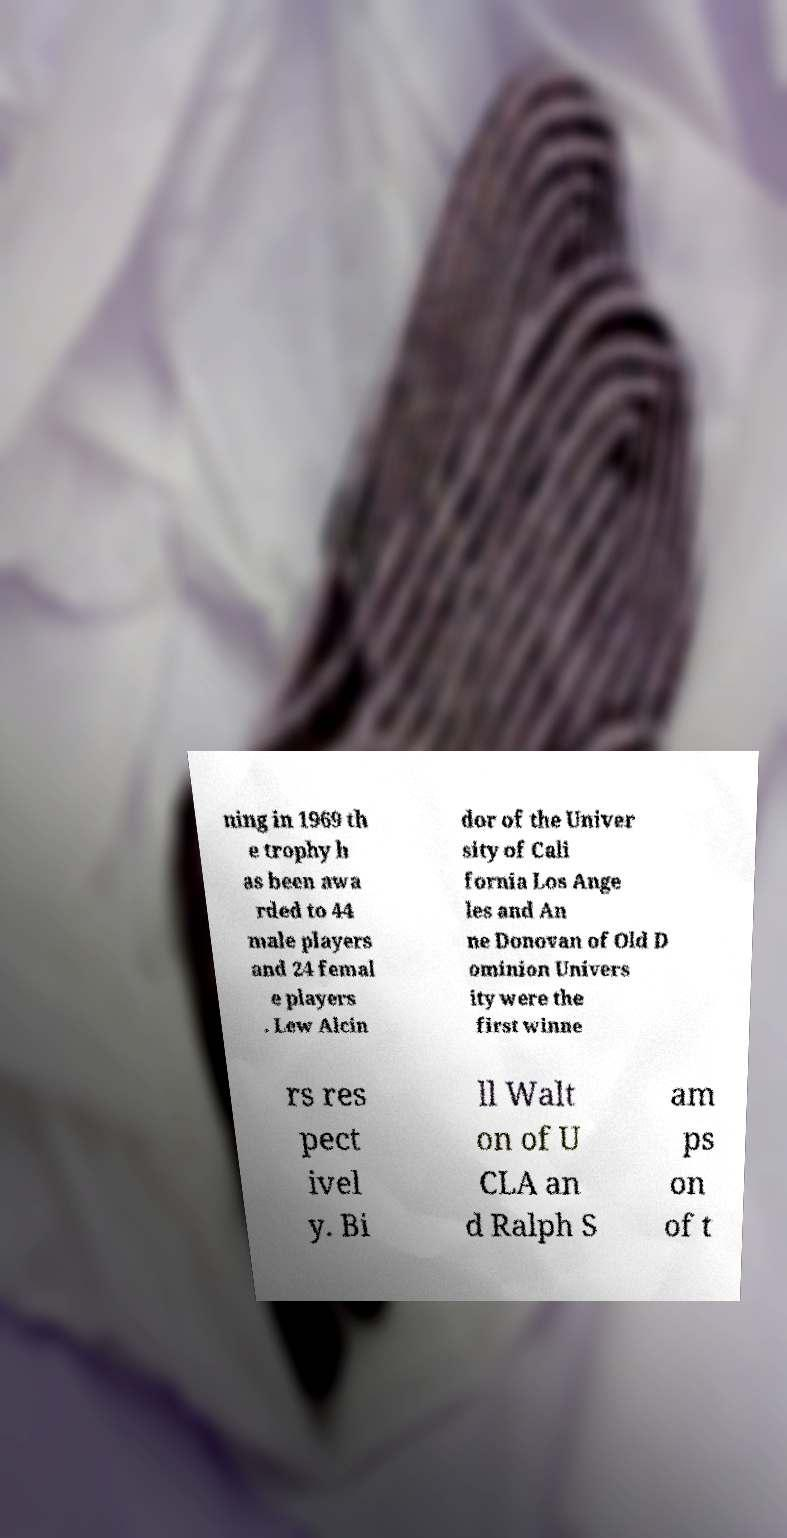I need the written content from this picture converted into text. Can you do that? ning in 1969 th e trophy h as been awa rded to 44 male players and 24 femal e players . Lew Alcin dor of the Univer sity of Cali fornia Los Ange les and An ne Donovan of Old D ominion Univers ity were the first winne rs res pect ivel y. Bi ll Walt on of U CLA an d Ralph S am ps on of t 